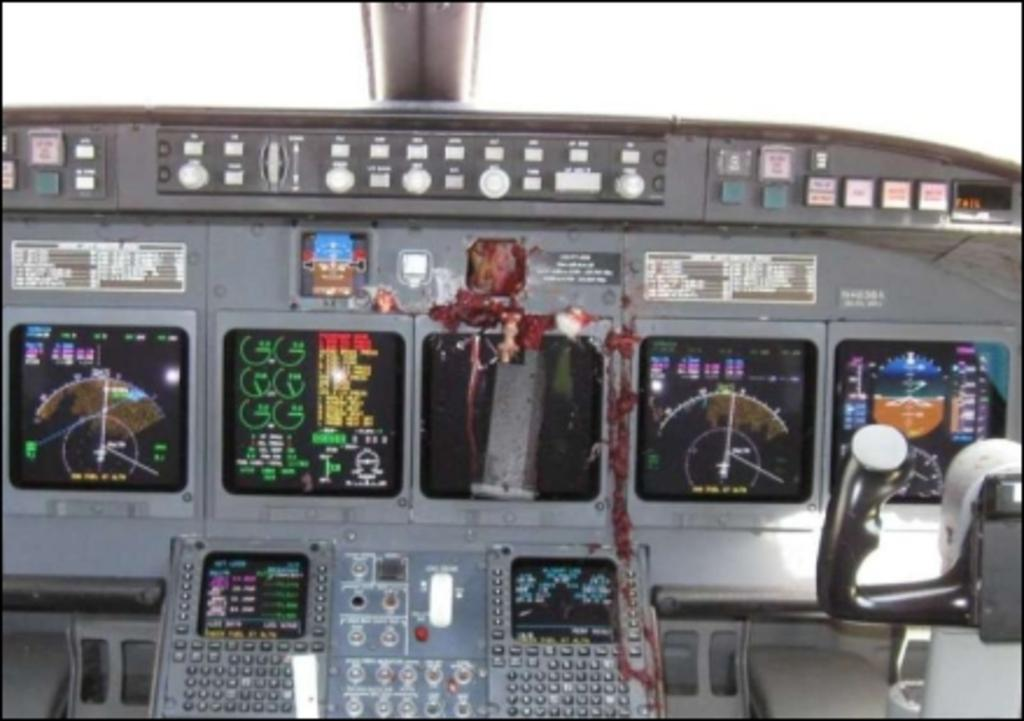What object is located on the right side of the image? There is a controller on the right side of the image. Where is the controller situated? The controller is on the dashboard of an aircraft. What types of items can be seen on the dashboard? There are display boards, buttons, lights, and other objects on the dashboard. What is the color of the background in the image? The background of the image is white. How many eyes can be seen on the dashboard in the image? There are no eyes visible on the dashboard in the image. What type of noise can be heard coming from the aircraft in the image? There is no indication of sound or noise in the image, as it is a still photograph. 